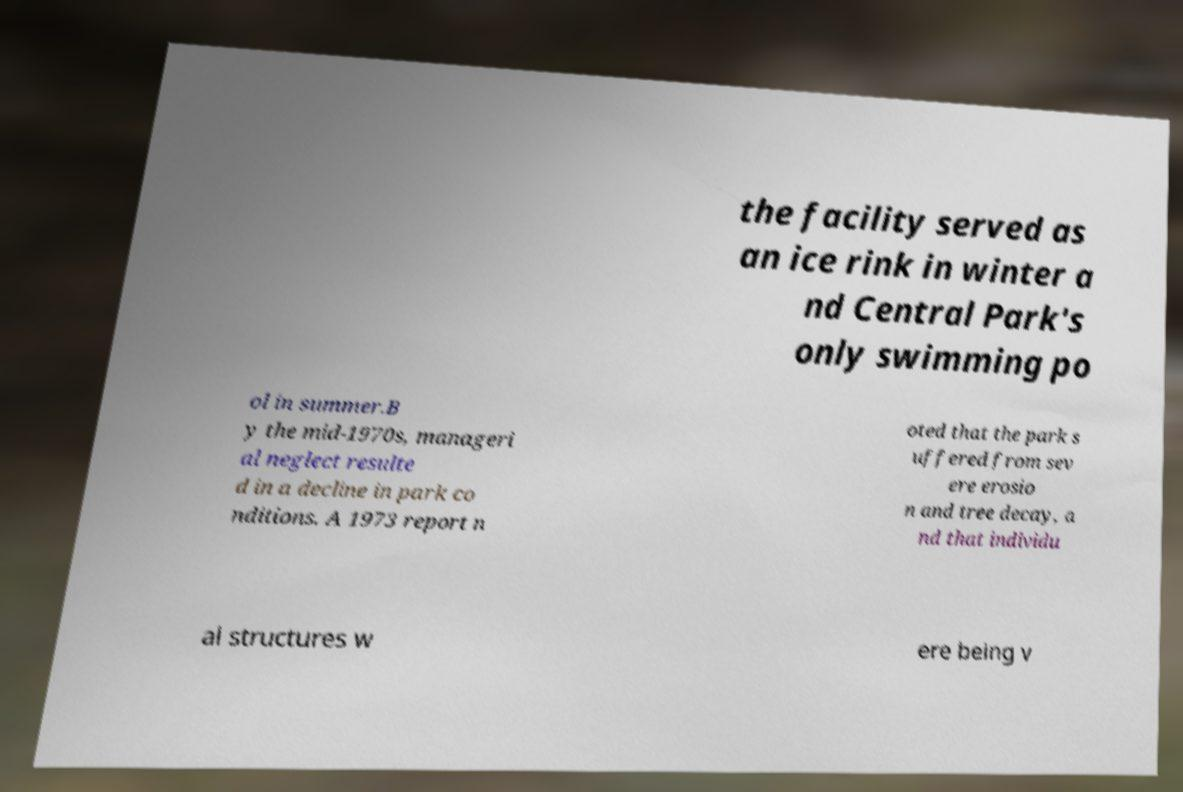There's text embedded in this image that I need extracted. Can you transcribe it verbatim? the facility served as an ice rink in winter a nd Central Park's only swimming po ol in summer.B y the mid-1970s, manageri al neglect resulte d in a decline in park co nditions. A 1973 report n oted that the park s uffered from sev ere erosio n and tree decay, a nd that individu al structures w ere being v 